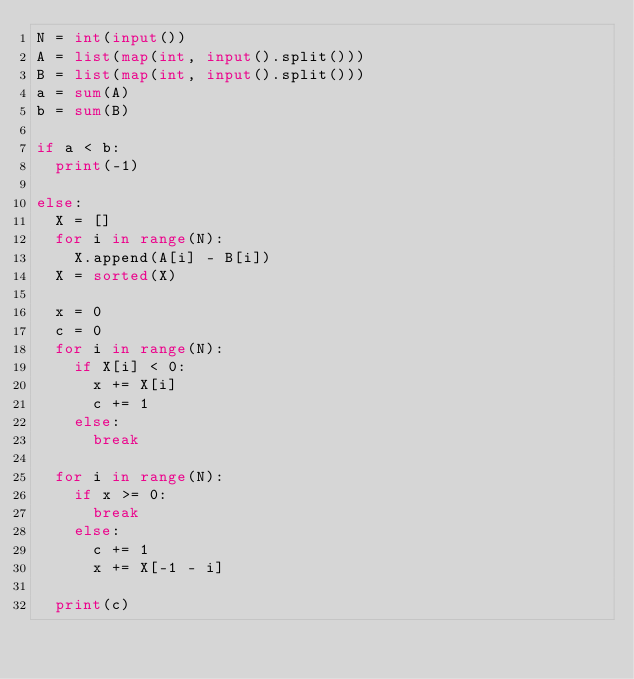Convert code to text. <code><loc_0><loc_0><loc_500><loc_500><_Python_>N = int(input())
A = list(map(int, input().split()))
B = list(map(int, input().split()))
a = sum(A)
b = sum(B)

if a < b:
	print(-1)

else:
	X = []
	for i in range(N):
		X.append(A[i] - B[i])
	X = sorted(X)
	
	x = 0
	c = 0
	for i in range(N):
		if X[i] < 0:
			x += X[i]
			c += 1
		else:
			break

	for i in range(N):
		if x >= 0:
			break
		else:
			c += 1
			x += X[-1 - i]

	print(c)</code> 